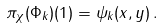Convert formula to latex. <formula><loc_0><loc_0><loc_500><loc_500>\pi _ { \chi } ( \Phi _ { k } ) ( 1 ) = \psi _ { k } ( x , y ) \, .</formula> 